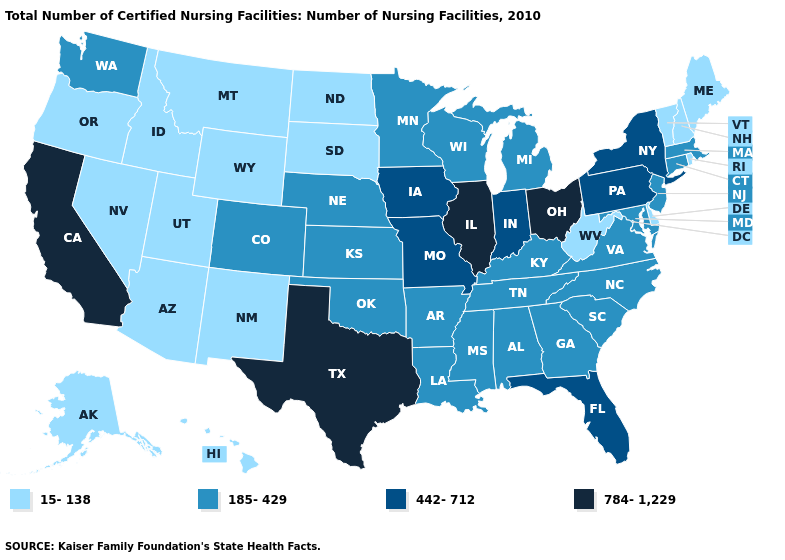Among the states that border Delaware , does Pennsylvania have the highest value?
Concise answer only. Yes. How many symbols are there in the legend?
Short answer required. 4. Which states have the lowest value in the USA?
Concise answer only. Alaska, Arizona, Delaware, Hawaii, Idaho, Maine, Montana, Nevada, New Hampshire, New Mexico, North Dakota, Oregon, Rhode Island, South Dakota, Utah, Vermont, West Virginia, Wyoming. Name the states that have a value in the range 185-429?
Be succinct. Alabama, Arkansas, Colorado, Connecticut, Georgia, Kansas, Kentucky, Louisiana, Maryland, Massachusetts, Michigan, Minnesota, Mississippi, Nebraska, New Jersey, North Carolina, Oklahoma, South Carolina, Tennessee, Virginia, Washington, Wisconsin. Which states have the highest value in the USA?
Keep it brief. California, Illinois, Ohio, Texas. What is the lowest value in states that border Wyoming?
Write a very short answer. 15-138. Name the states that have a value in the range 784-1,229?
Write a very short answer. California, Illinois, Ohio, Texas. What is the highest value in states that border Vermont?
Short answer required. 442-712. Which states have the lowest value in the South?
Give a very brief answer. Delaware, West Virginia. What is the value of Texas?
Answer briefly. 784-1,229. Among the states that border Vermont , which have the highest value?
Short answer required. New York. What is the lowest value in the USA?
Give a very brief answer. 15-138. Name the states that have a value in the range 185-429?
Answer briefly. Alabama, Arkansas, Colorado, Connecticut, Georgia, Kansas, Kentucky, Louisiana, Maryland, Massachusetts, Michigan, Minnesota, Mississippi, Nebraska, New Jersey, North Carolina, Oklahoma, South Carolina, Tennessee, Virginia, Washington, Wisconsin. What is the value of Wyoming?
Answer briefly. 15-138. Name the states that have a value in the range 15-138?
Short answer required. Alaska, Arizona, Delaware, Hawaii, Idaho, Maine, Montana, Nevada, New Hampshire, New Mexico, North Dakota, Oregon, Rhode Island, South Dakota, Utah, Vermont, West Virginia, Wyoming. 